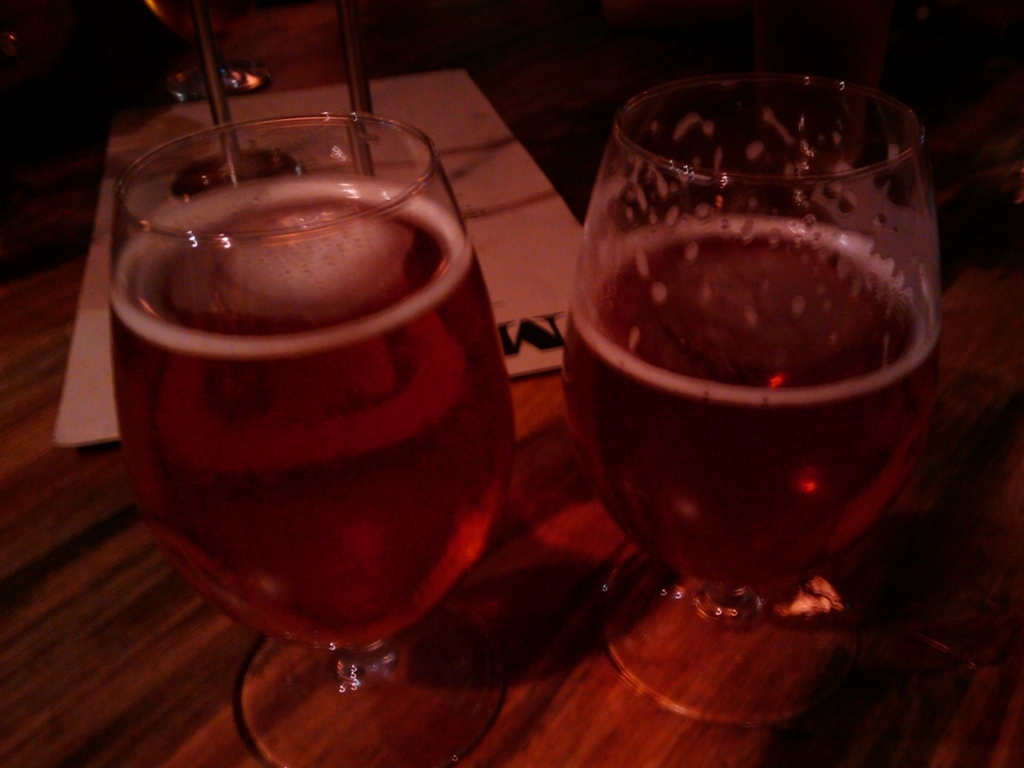What could be the setting where this image was taken? The setting appears to be an indoor environment, likely a bar or restaurant. The warm, dim lighting and the wooden surface suggest a cozy, casual atmosphere typical of such establishments. 